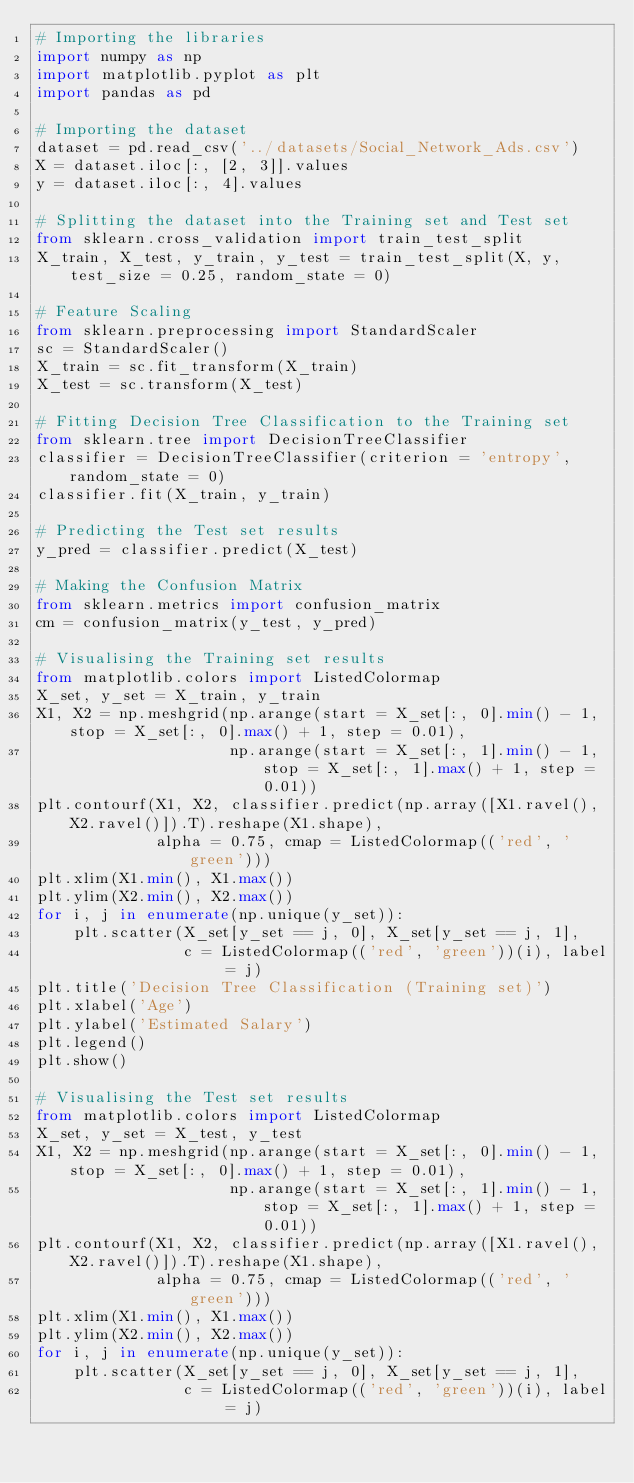Convert code to text. <code><loc_0><loc_0><loc_500><loc_500><_Python_># Importing the libraries
import numpy as np
import matplotlib.pyplot as plt
import pandas as pd

# Importing the dataset
dataset = pd.read_csv('../datasets/Social_Network_Ads.csv')
X = dataset.iloc[:, [2, 3]].values
y = dataset.iloc[:, 4].values

# Splitting the dataset into the Training set and Test set
from sklearn.cross_validation import train_test_split
X_train, X_test, y_train, y_test = train_test_split(X, y, test_size = 0.25, random_state = 0)

# Feature Scaling
from sklearn.preprocessing import StandardScaler
sc = StandardScaler()
X_train = sc.fit_transform(X_train)
X_test = sc.transform(X_test)

# Fitting Decision Tree Classification to the Training set
from sklearn.tree import DecisionTreeClassifier
classifier = DecisionTreeClassifier(criterion = 'entropy', random_state = 0)
classifier.fit(X_train, y_train)

# Predicting the Test set results
y_pred = classifier.predict(X_test)

# Making the Confusion Matrix
from sklearn.metrics import confusion_matrix
cm = confusion_matrix(y_test, y_pred)

# Visualising the Training set results
from matplotlib.colors import ListedColormap
X_set, y_set = X_train, y_train
X1, X2 = np.meshgrid(np.arange(start = X_set[:, 0].min() - 1, stop = X_set[:, 0].max() + 1, step = 0.01),
                     np.arange(start = X_set[:, 1].min() - 1, stop = X_set[:, 1].max() + 1, step = 0.01))
plt.contourf(X1, X2, classifier.predict(np.array([X1.ravel(), X2.ravel()]).T).reshape(X1.shape),
             alpha = 0.75, cmap = ListedColormap(('red', 'green')))
plt.xlim(X1.min(), X1.max())
plt.ylim(X2.min(), X2.max())
for i, j in enumerate(np.unique(y_set)):
    plt.scatter(X_set[y_set == j, 0], X_set[y_set == j, 1],
                c = ListedColormap(('red', 'green'))(i), label = j)
plt.title('Decision Tree Classification (Training set)')
plt.xlabel('Age')
plt.ylabel('Estimated Salary')
plt.legend()
plt.show()

# Visualising the Test set results
from matplotlib.colors import ListedColormap
X_set, y_set = X_test, y_test
X1, X2 = np.meshgrid(np.arange(start = X_set[:, 0].min() - 1, stop = X_set[:, 0].max() + 1, step = 0.01),
                     np.arange(start = X_set[:, 1].min() - 1, stop = X_set[:, 1].max() + 1, step = 0.01))
plt.contourf(X1, X2, classifier.predict(np.array([X1.ravel(), X2.ravel()]).T).reshape(X1.shape),
             alpha = 0.75, cmap = ListedColormap(('red', 'green')))
plt.xlim(X1.min(), X1.max())
plt.ylim(X2.min(), X2.max())
for i, j in enumerate(np.unique(y_set)):
    plt.scatter(X_set[y_set == j, 0], X_set[y_set == j, 1],
                c = ListedColormap(('red', 'green'))(i), label = j)</code> 